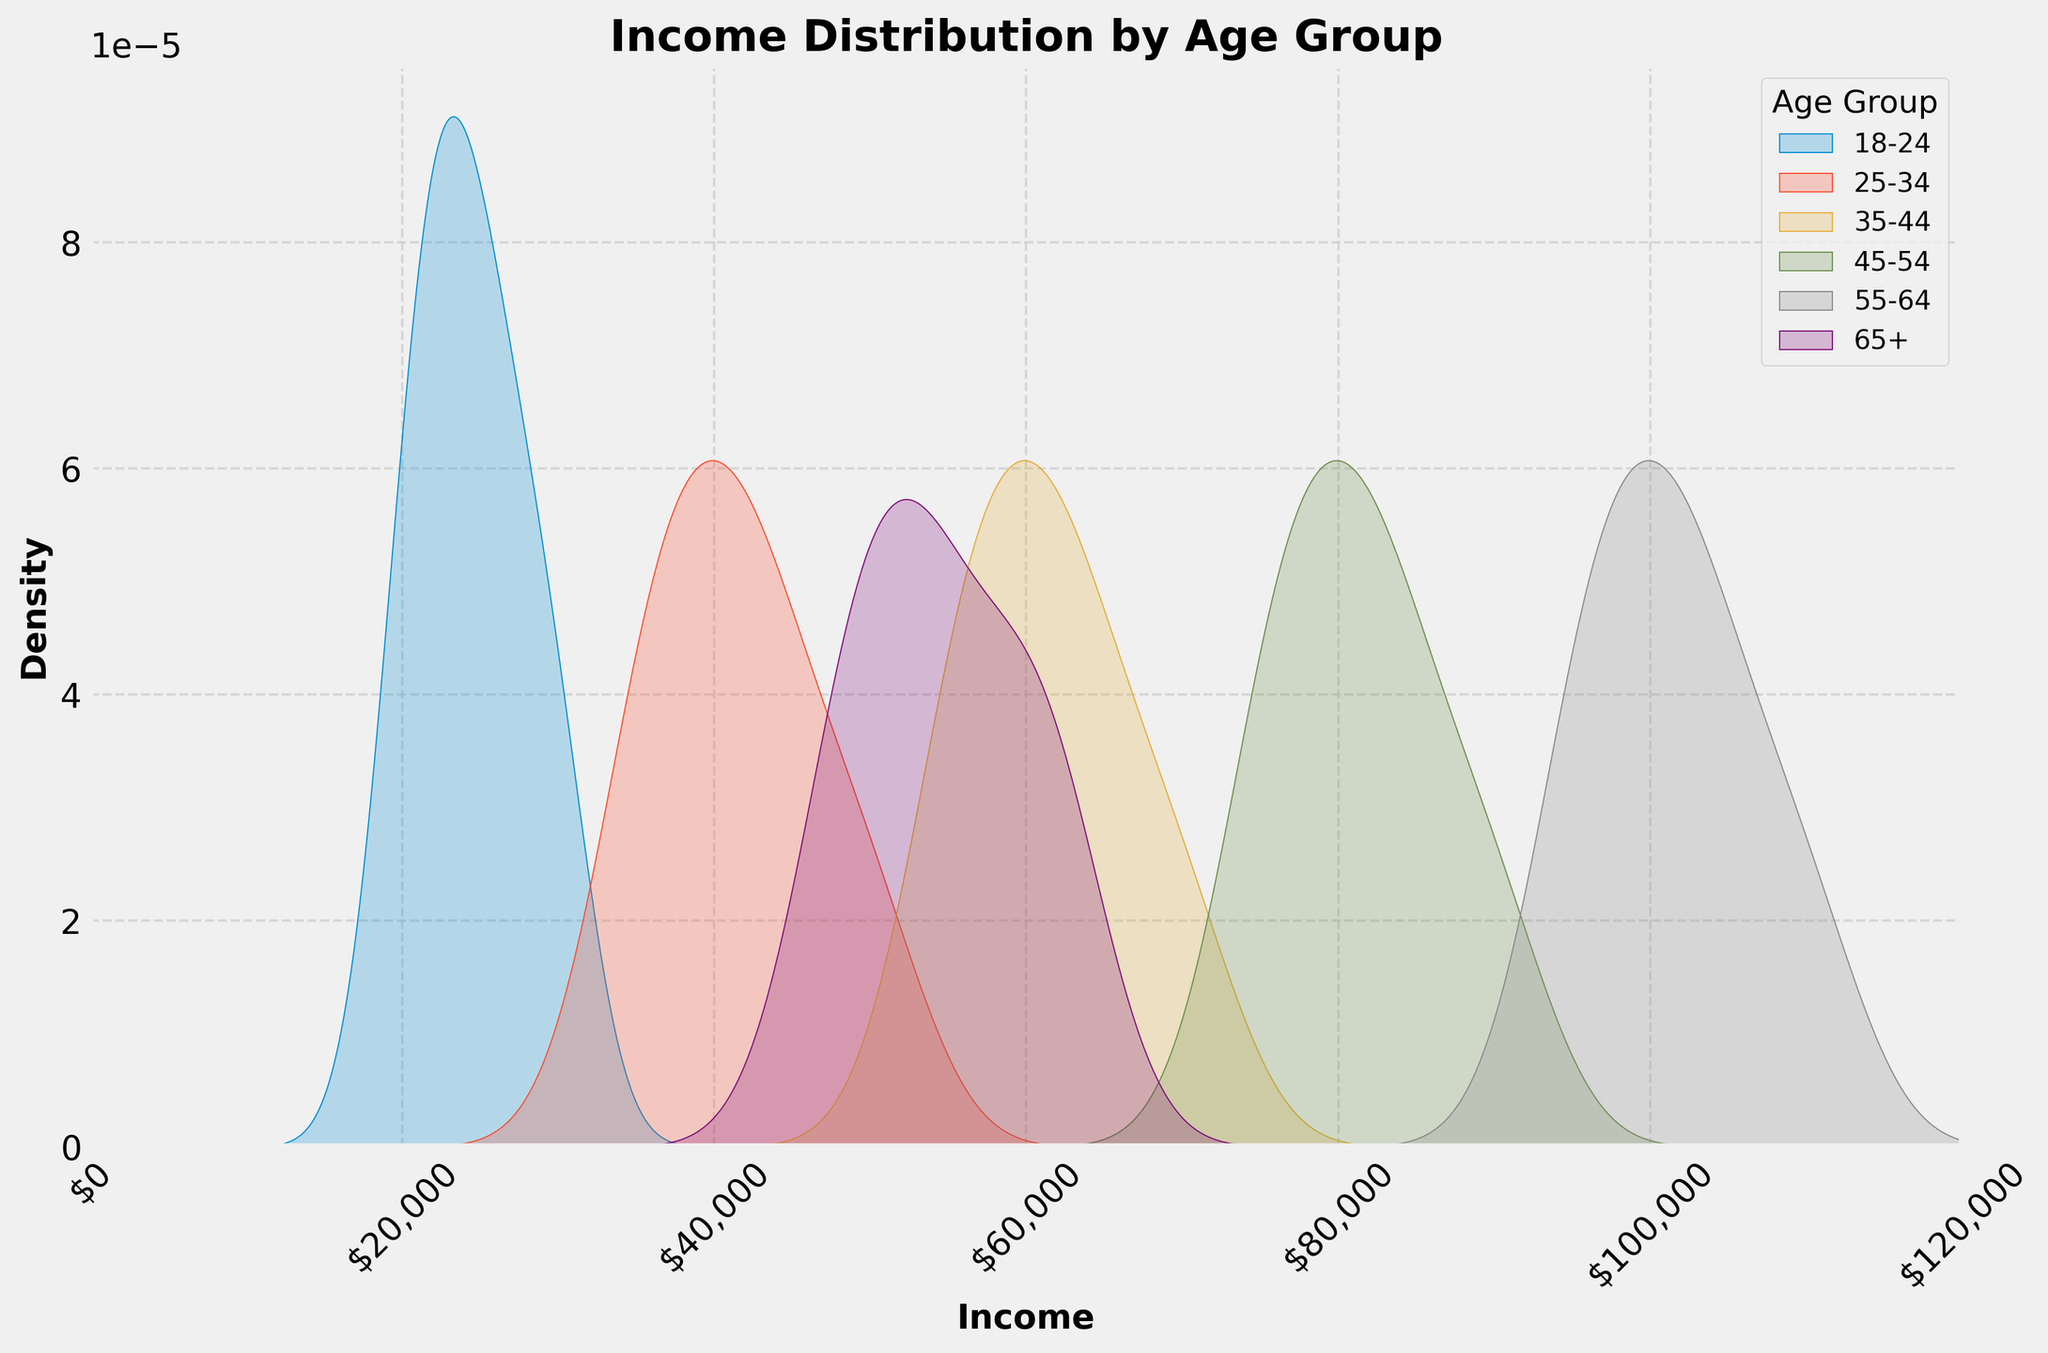What is the title of the figure? The title of the figure is located at the top center of the plot. It provides a brief description of the plot's content.
Answer: Income Distribution by Age Group Which age group has the highest peak in their income distribution? By observing the peaks of the different density distributions, we can identify which age group's curve reaches the highest point on the y-axis, indicating the highest density of incomes.
Answer: 55-64 Where does the 18-24 age group's density peak in terms of income level? The peak of the density curve for the 18-24 age group represents the most common income level within this group. By following the 18-24 line to its highest point, we then look immediately below to identify the income level on the x-axis.
Answer: Around $25,000 Which age group shows a broader range of income distribution? A broader range of income distribution is indicated by a wider spread of the density curve across the x-axis. Observing the extents of each age group's curve will provide the answer.
Answer: 55-64 How do the income distributions of the 45-54 and 65+ age groups compare in terms of spread? By comparing the spreads of the density curves for the 45-54 and 65+ age groups, we can observe which group has a more concentrated income range and which one is more spread out.
Answer: 65+ has a more concentrated income distribution, while 45-54 is more spread out Which age group has the lowest density in the higher income range (above $90,000)? To answer this, we should observe the density curves in the income range above $90,000 and identify which age group has the least presence or lowest density within this range.
Answer: 18-24 and 65+ Do any age groups have overlapping income distributions? To determine overlap between income distributions, examine where the density curves of different age groups intersect or share the same range on the x-axis.
Answer: Yes, 25-34 and 35-44 show significant overlap What is the approximate income range for the most common incomes in the 35-44 age group? By looking at the highest density part of the 35-44 age group’s curve, we can estimate the income range that covers the most common incomes.
Answer: $55,000 to $70,000 